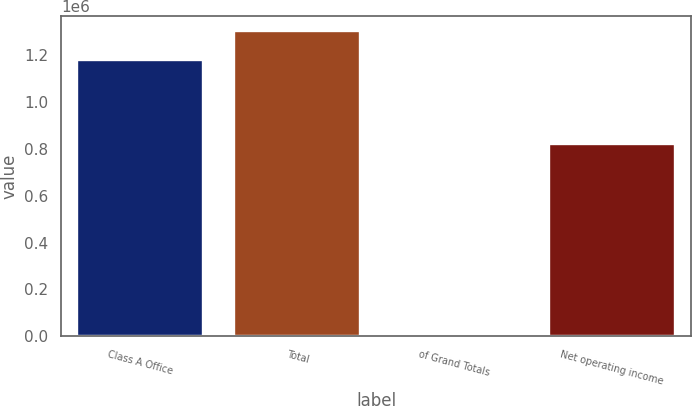Convert chart. <chart><loc_0><loc_0><loc_500><loc_500><bar_chart><fcel>Class A Office<fcel>Total<fcel>of Grand Totals<fcel>Net operating income<nl><fcel>1.17808e+06<fcel>1.30435e+06<fcel>100<fcel>822122<nl></chart> 